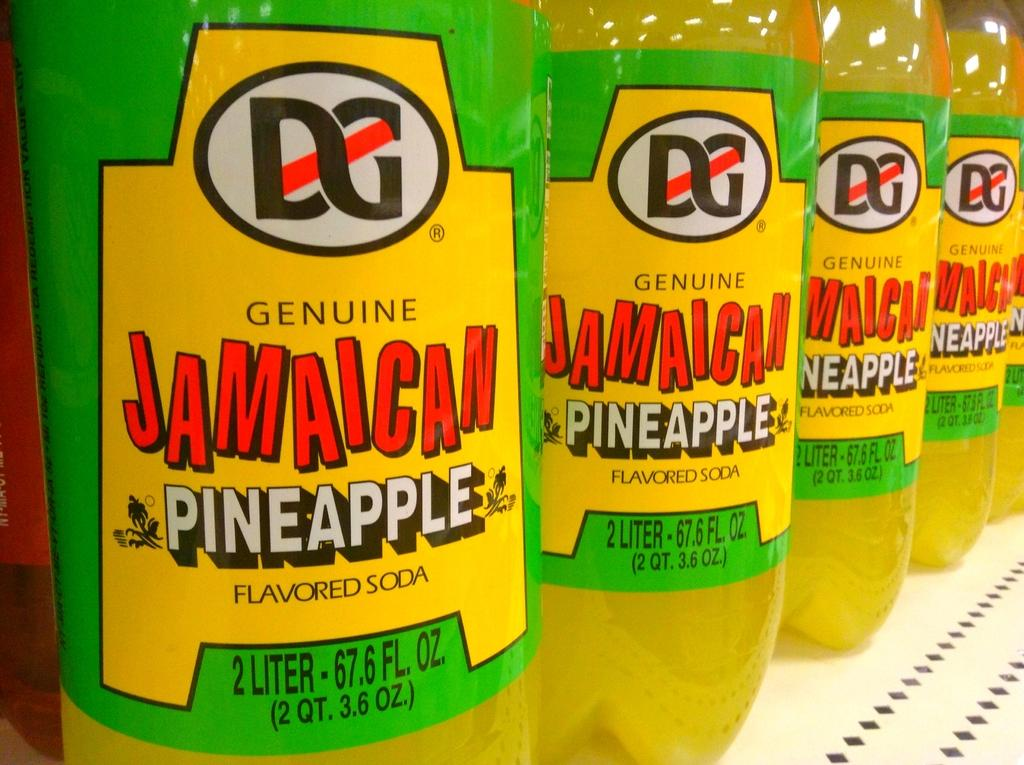<image>
Describe the image concisely. a row of genuine jamaican pineapple flavored soda 